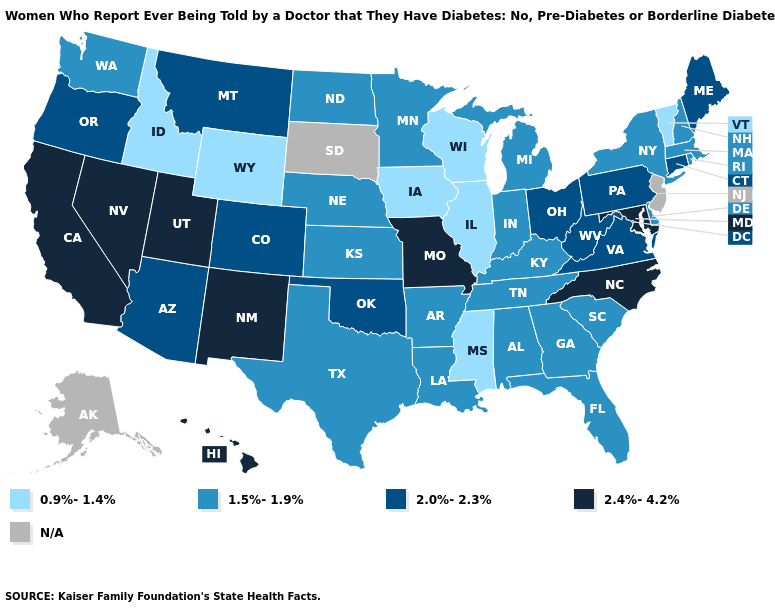Does the first symbol in the legend represent the smallest category?
Keep it brief. Yes. What is the lowest value in states that border Wyoming?
Give a very brief answer. 0.9%-1.4%. Name the states that have a value in the range 2.0%-2.3%?
Answer briefly. Arizona, Colorado, Connecticut, Maine, Montana, Ohio, Oklahoma, Oregon, Pennsylvania, Virginia, West Virginia. Does Wisconsin have the lowest value in the MidWest?
Keep it brief. Yes. What is the lowest value in the USA?
Write a very short answer. 0.9%-1.4%. What is the lowest value in states that border Oregon?
Short answer required. 0.9%-1.4%. What is the highest value in the South ?
Be succinct. 2.4%-4.2%. Name the states that have a value in the range 2.4%-4.2%?
Write a very short answer. California, Hawaii, Maryland, Missouri, Nevada, New Mexico, North Carolina, Utah. Name the states that have a value in the range N/A?
Answer briefly. Alaska, New Jersey, South Dakota. What is the value of Indiana?
Give a very brief answer. 1.5%-1.9%. What is the highest value in states that border Minnesota?
Keep it brief. 1.5%-1.9%. Which states have the lowest value in the USA?
Write a very short answer. Idaho, Illinois, Iowa, Mississippi, Vermont, Wisconsin, Wyoming. Does the first symbol in the legend represent the smallest category?
Quick response, please. Yes. Which states hav the highest value in the South?
Quick response, please. Maryland, North Carolina. Does the first symbol in the legend represent the smallest category?
Write a very short answer. Yes. 